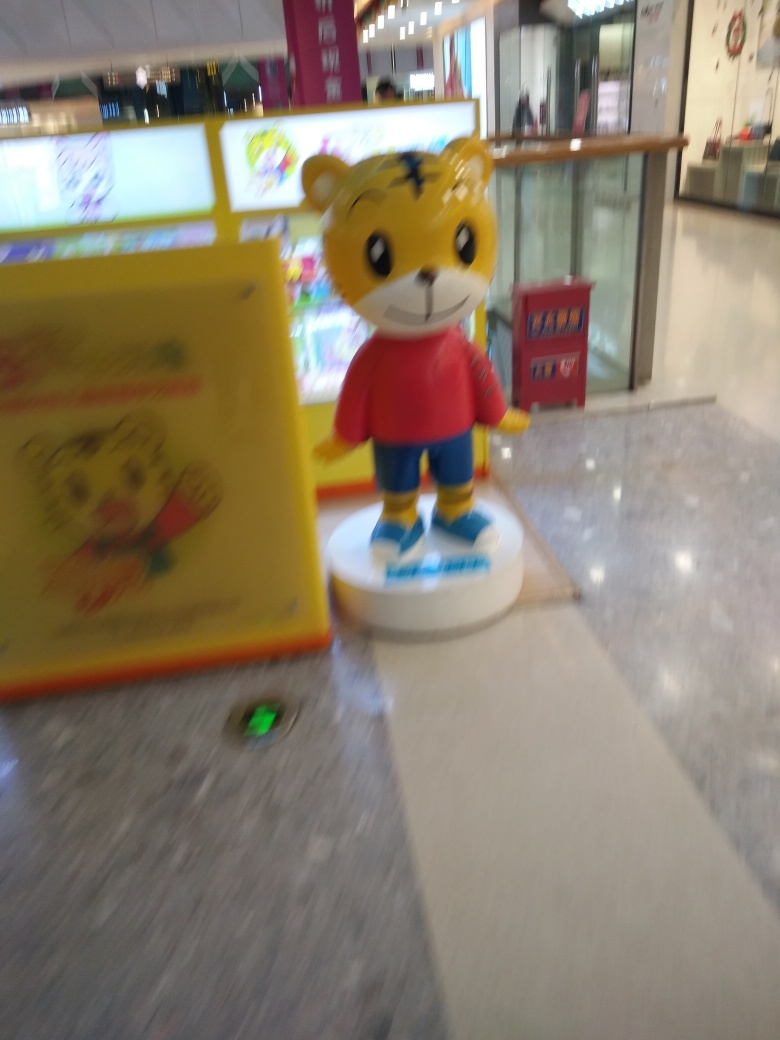Can you tell what kind of environment or setting this character is in? Despite the blurriness, it appears that the character is in an indoor setting, likely a shopping mall or a recreational area, given the presence of advertisement boards and what seems to be storefronts in the background. 